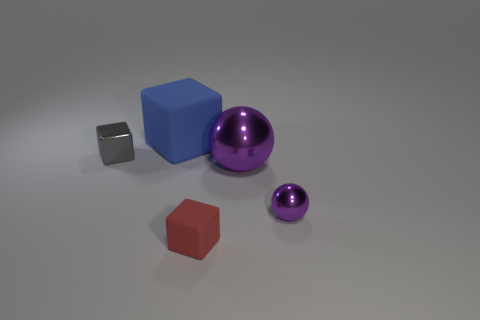Subtract all big blue matte blocks. How many blocks are left? 2 Add 5 blue rubber things. How many objects exist? 10 Subtract all spheres. How many objects are left? 3 Add 5 blue matte cubes. How many blue matte cubes are left? 6 Add 5 red matte objects. How many red matte objects exist? 6 Subtract 0 cyan blocks. How many objects are left? 5 Subtract all yellow cubes. Subtract all gray cylinders. How many cubes are left? 3 Subtract all tiny purple shiny things. Subtract all tiny gray blocks. How many objects are left? 3 